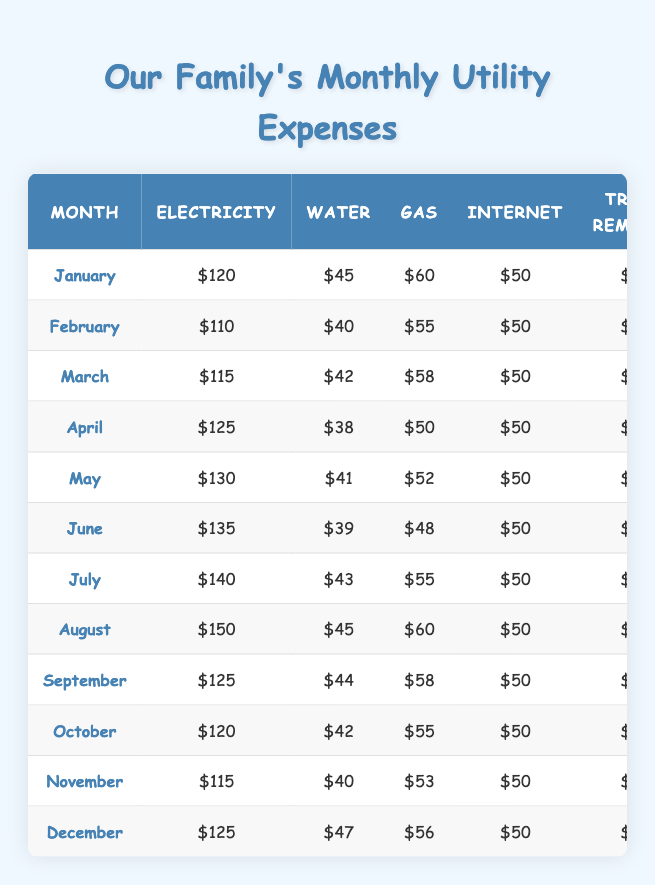What was the total utility expense in August? The table shows that for August, the total utility expense is listed as $415.
Answer: $415 Which month had the highest electricity bill? In the table, August shows the highest electricity bill at $150.
Answer: August What is the average water bill for the year? Summing the water bills for each month gives (45 + 40 + 42 + 38 + 41 + 39 + 43 + 45 + 44 + 42 + 40 + 47) = 510. There are 12 months, so the average is 510 / 12 = 42.5.
Answer: 42.5 Did the total utility expenses increase from June to July? In the table, June's total is $382 and July's total is $398; thus, it increased by $16.
Answer: Yes What is the difference between the total utility expenses in January and November? The total for January is $385 and for November is $368. The difference is $385 - $368 = $17.
Answer: $17 Which month had the lowest total utility expense? Reviewing the table, February has the lowest total of $365.
Answer: February How much did the gas bill vary from the highest to the lowest in the year? The highest gas bill appears in August at $60, and the lowest in April at $50, giving a variance of $60 - $50 = $10.
Answer: $10 Is the average total utility expense higher in the second half of the year compared to the first half? The total expenses for the first half are (385 + 365 + 375 + 373 + 383 + 382) = 2253. For the second half (398 + 415 + 387 + 377 + 368 + 388) = 2293. The averages are 2253 / 6 = 375.5 and 2293 / 6 = 382.2, so yes, it is higher in the second half.
Answer: Yes What is the total expenditure on trash removal for the entire year? Each month lists the same trash removal expense of $30. For 12 months, the total is 30 * 12 = $360.
Answer: $360 How do the utility expenses in December compare with the expenses in January? The total for December is $388 and for January is $385. December's expenses are higher by $3.
Answer: December is higher by $3 